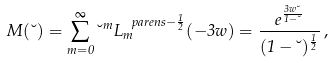<formula> <loc_0><loc_0><loc_500><loc_500>M ( \lambda ) = \sum _ { m = 0 } ^ { \infty } \lambda ^ { m } L _ { m } ^ { \ p a r e n s { - \frac { 1 } { 2 } } } ( - 3 w ) = \frac { e ^ { \frac { 3 w \lambda } { 1 - \lambda } } } { ( 1 - \lambda ) ^ { \frac { 1 } { 2 } } } \, ,</formula> 